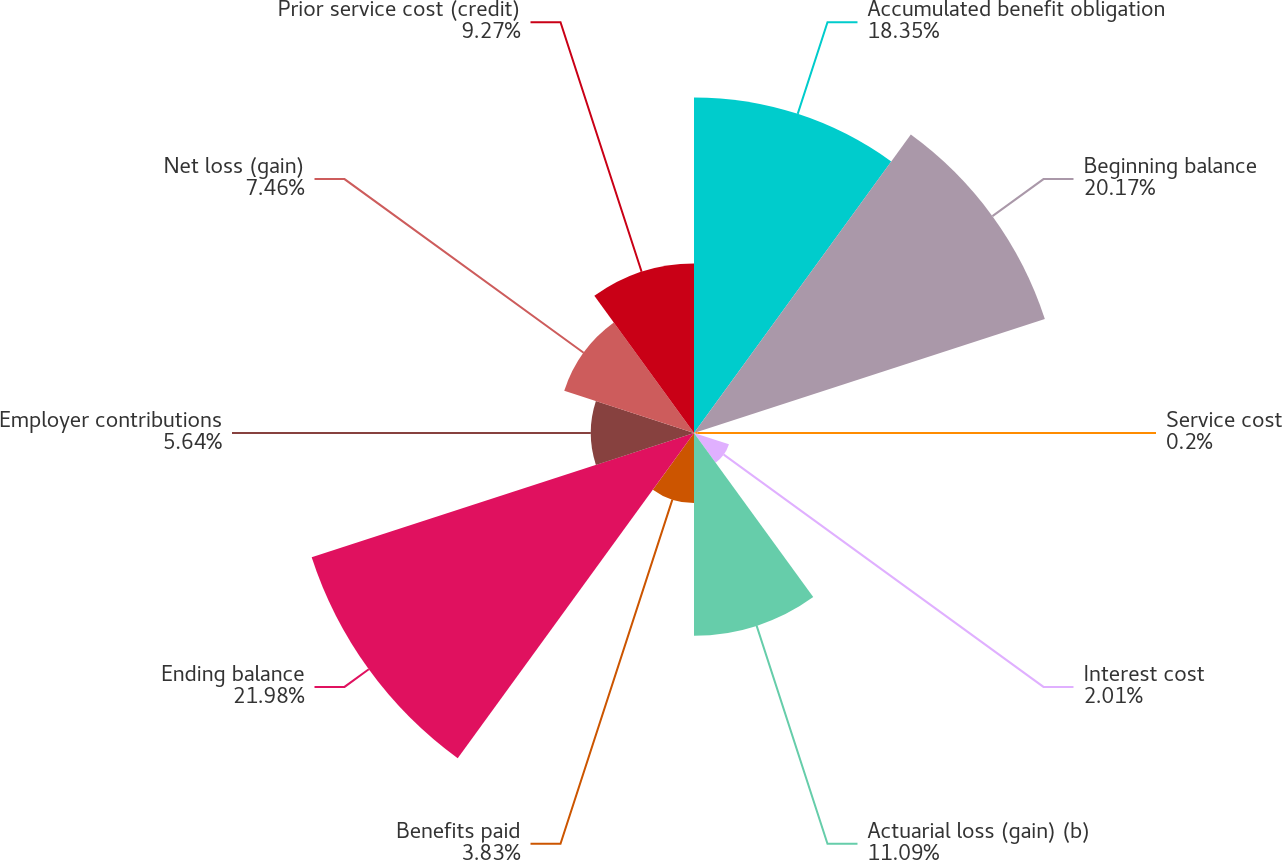Convert chart to OTSL. <chart><loc_0><loc_0><loc_500><loc_500><pie_chart><fcel>Accumulated benefit obligation<fcel>Beginning balance<fcel>Service cost<fcel>Interest cost<fcel>Actuarial loss (gain) (b)<fcel>Benefits paid<fcel>Ending balance<fcel>Employer contributions<fcel>Net loss (gain)<fcel>Prior service cost (credit)<nl><fcel>18.35%<fcel>20.17%<fcel>0.2%<fcel>2.01%<fcel>11.09%<fcel>3.83%<fcel>21.98%<fcel>5.64%<fcel>7.46%<fcel>9.27%<nl></chart> 